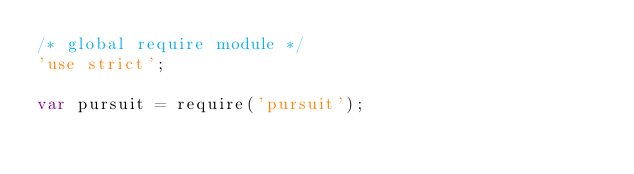Convert code to text. <code><loc_0><loc_0><loc_500><loc_500><_JavaScript_>/* global require module */
'use strict';

var pursuit = require('pursuit');</code> 